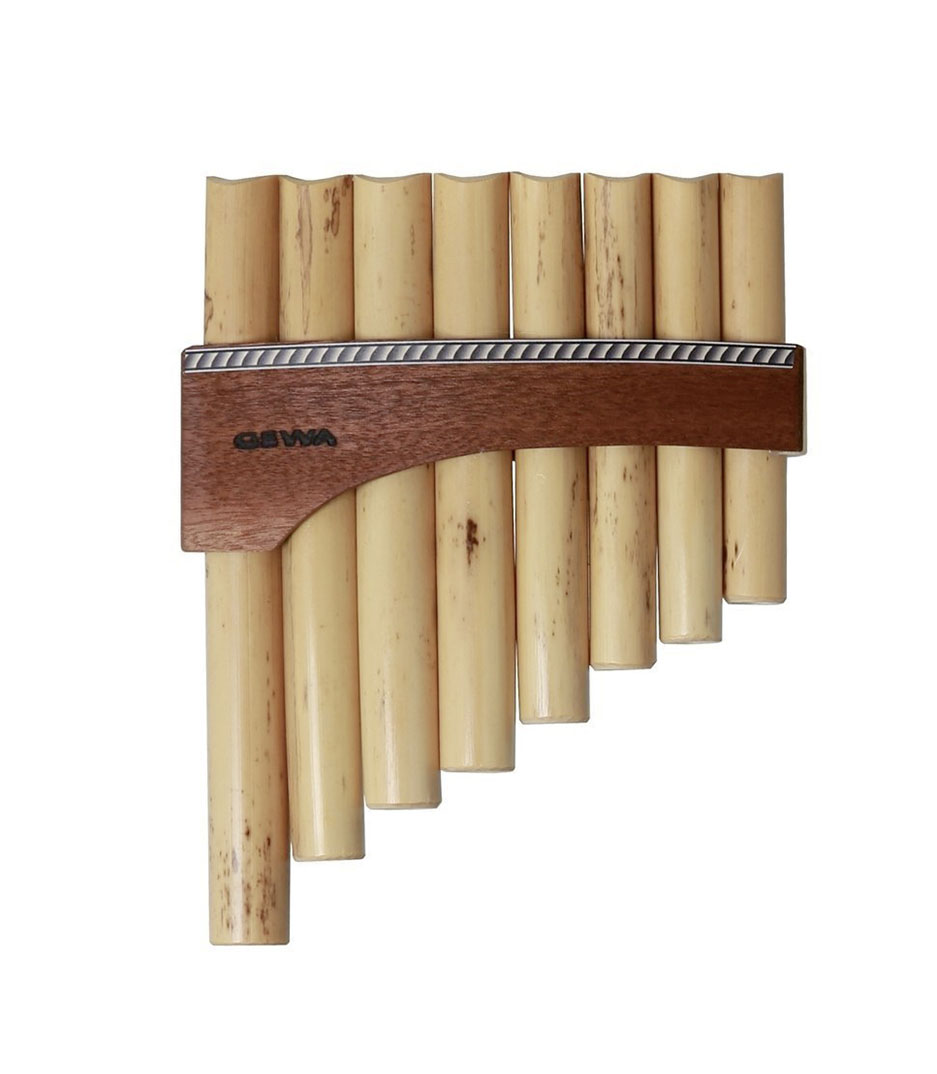What are some historical uses of the pan flute in different cultures? The pan flute has been cherished across various cultures for centuries. In ancient Greece, it was associated with the pastoral god Pan, from whom the instrument derives its name. In Andean cultures, particularly those of Peru and Bolivia, the pan flute—known as the 'zampoña' or 'siku'—is an integral part of traditional music, often played in ensembles to create harmonious melodies that resonate with the region’s natural landscapes. Romanian folk music also prominently features the 'nai', a type of pan flute, adding a poignant, soulful tone to its rich musical heritage. Thus, the pan flute's diverse applications underscore its versatility and cultural significance. 